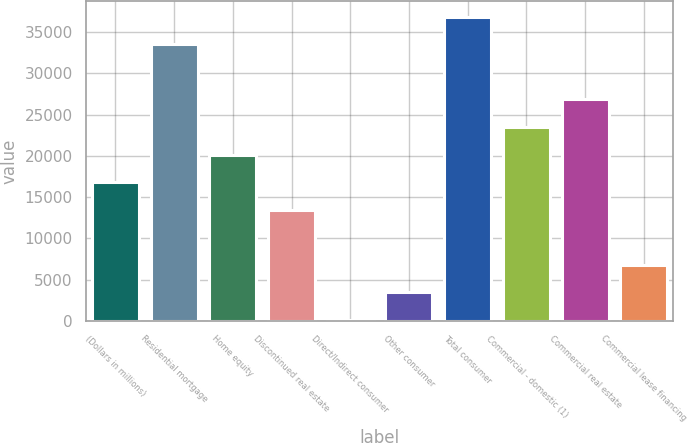Convert chart to OTSL. <chart><loc_0><loc_0><loc_500><loc_500><bar_chart><fcel>(Dollars in millions)<fcel>Residential mortgage<fcel>Home equity<fcel>Discontinued real estate<fcel>Direct/Indirect consumer<fcel>Other consumer<fcel>Total consumer<fcel>Commercial - domestic (1)<fcel>Commercial real estate<fcel>Commercial lease financing<nl><fcel>16814<fcel>33542<fcel>20159.6<fcel>13468.4<fcel>86<fcel>3431.6<fcel>36887.6<fcel>23505.2<fcel>26850.8<fcel>6777.2<nl></chart> 